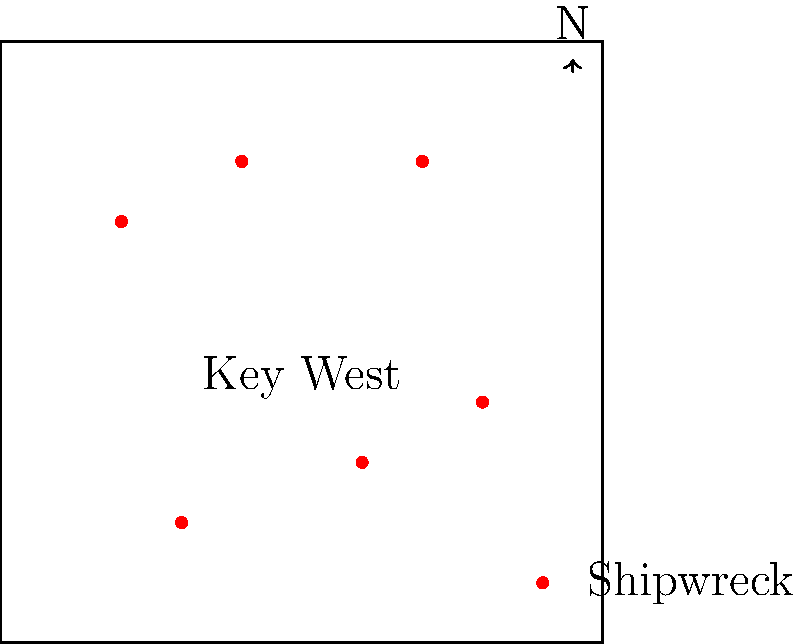Based on the nautical chart showing shipwrecks around Key West, which quadrant of the map contains the highest concentration of shipwrecks? Assume the origin (0,0) is at the center of Key West. To answer this question, we need to follow these steps:

1. Identify the quadrants:
   - Quadrant I: Upper right (positive x, positive y)
   - Quadrant II: Upper left (negative x, positive y)
   - Quadrant III: Lower left (negative x, negative y)
   - Quadrant IV: Lower right (positive x, negative y)

2. Count the number of shipwrecks in each quadrant:
   - Quadrant I: 2 shipwrecks
   - Quadrant II: 2 shipwrecks
   - Quadrant III: 1 shipwreck
   - Quadrant IV: 1 shipwreck

3. Determine which quadrant has the highest concentration:
   Quadrants I and II both have 2 shipwrecks, which is the highest count among all quadrants.

4. Consider historical context:
   As a local historian, you might know that the northern waters of Key West (Quadrants I and II) were more treacherous due to shallow reefs and strong currents, leading to a higher concentration of shipwrecks in these areas.

5. Make a final decision:
   Since both Quadrants I and II have the same number of shipwrecks, we can consider them equally correct. However, for the purpose of a single answer, we'll choose Quadrant I (upper right) as it's typically mentioned first when describing quadrants.
Answer: Quadrant I (upper right) 